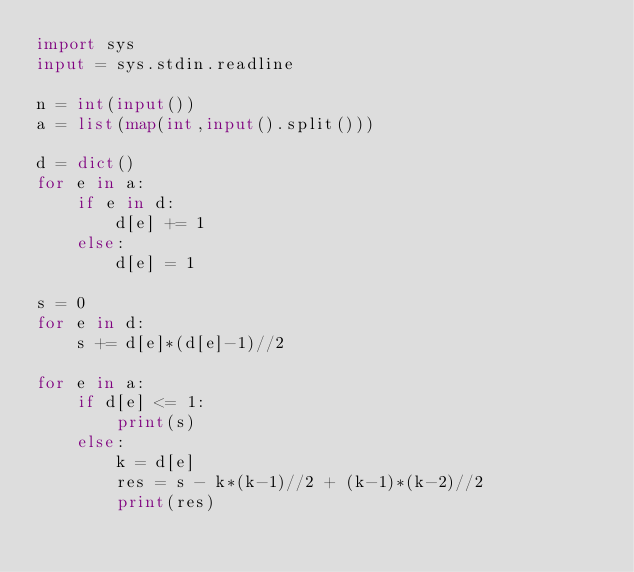<code> <loc_0><loc_0><loc_500><loc_500><_Python_>import sys
input = sys.stdin.readline
 
n = int(input())
a = list(map(int,input().split()))

d = dict()
for e in a:
    if e in d:
        d[e] += 1
    else:
        d[e] = 1

s = 0
for e in d:
    s += d[e]*(d[e]-1)//2

for e in a:
    if d[e] <= 1:
        print(s)
    else:
        k = d[e]
        res = s - k*(k-1)//2 + (k-1)*(k-2)//2
        print(res)</code> 